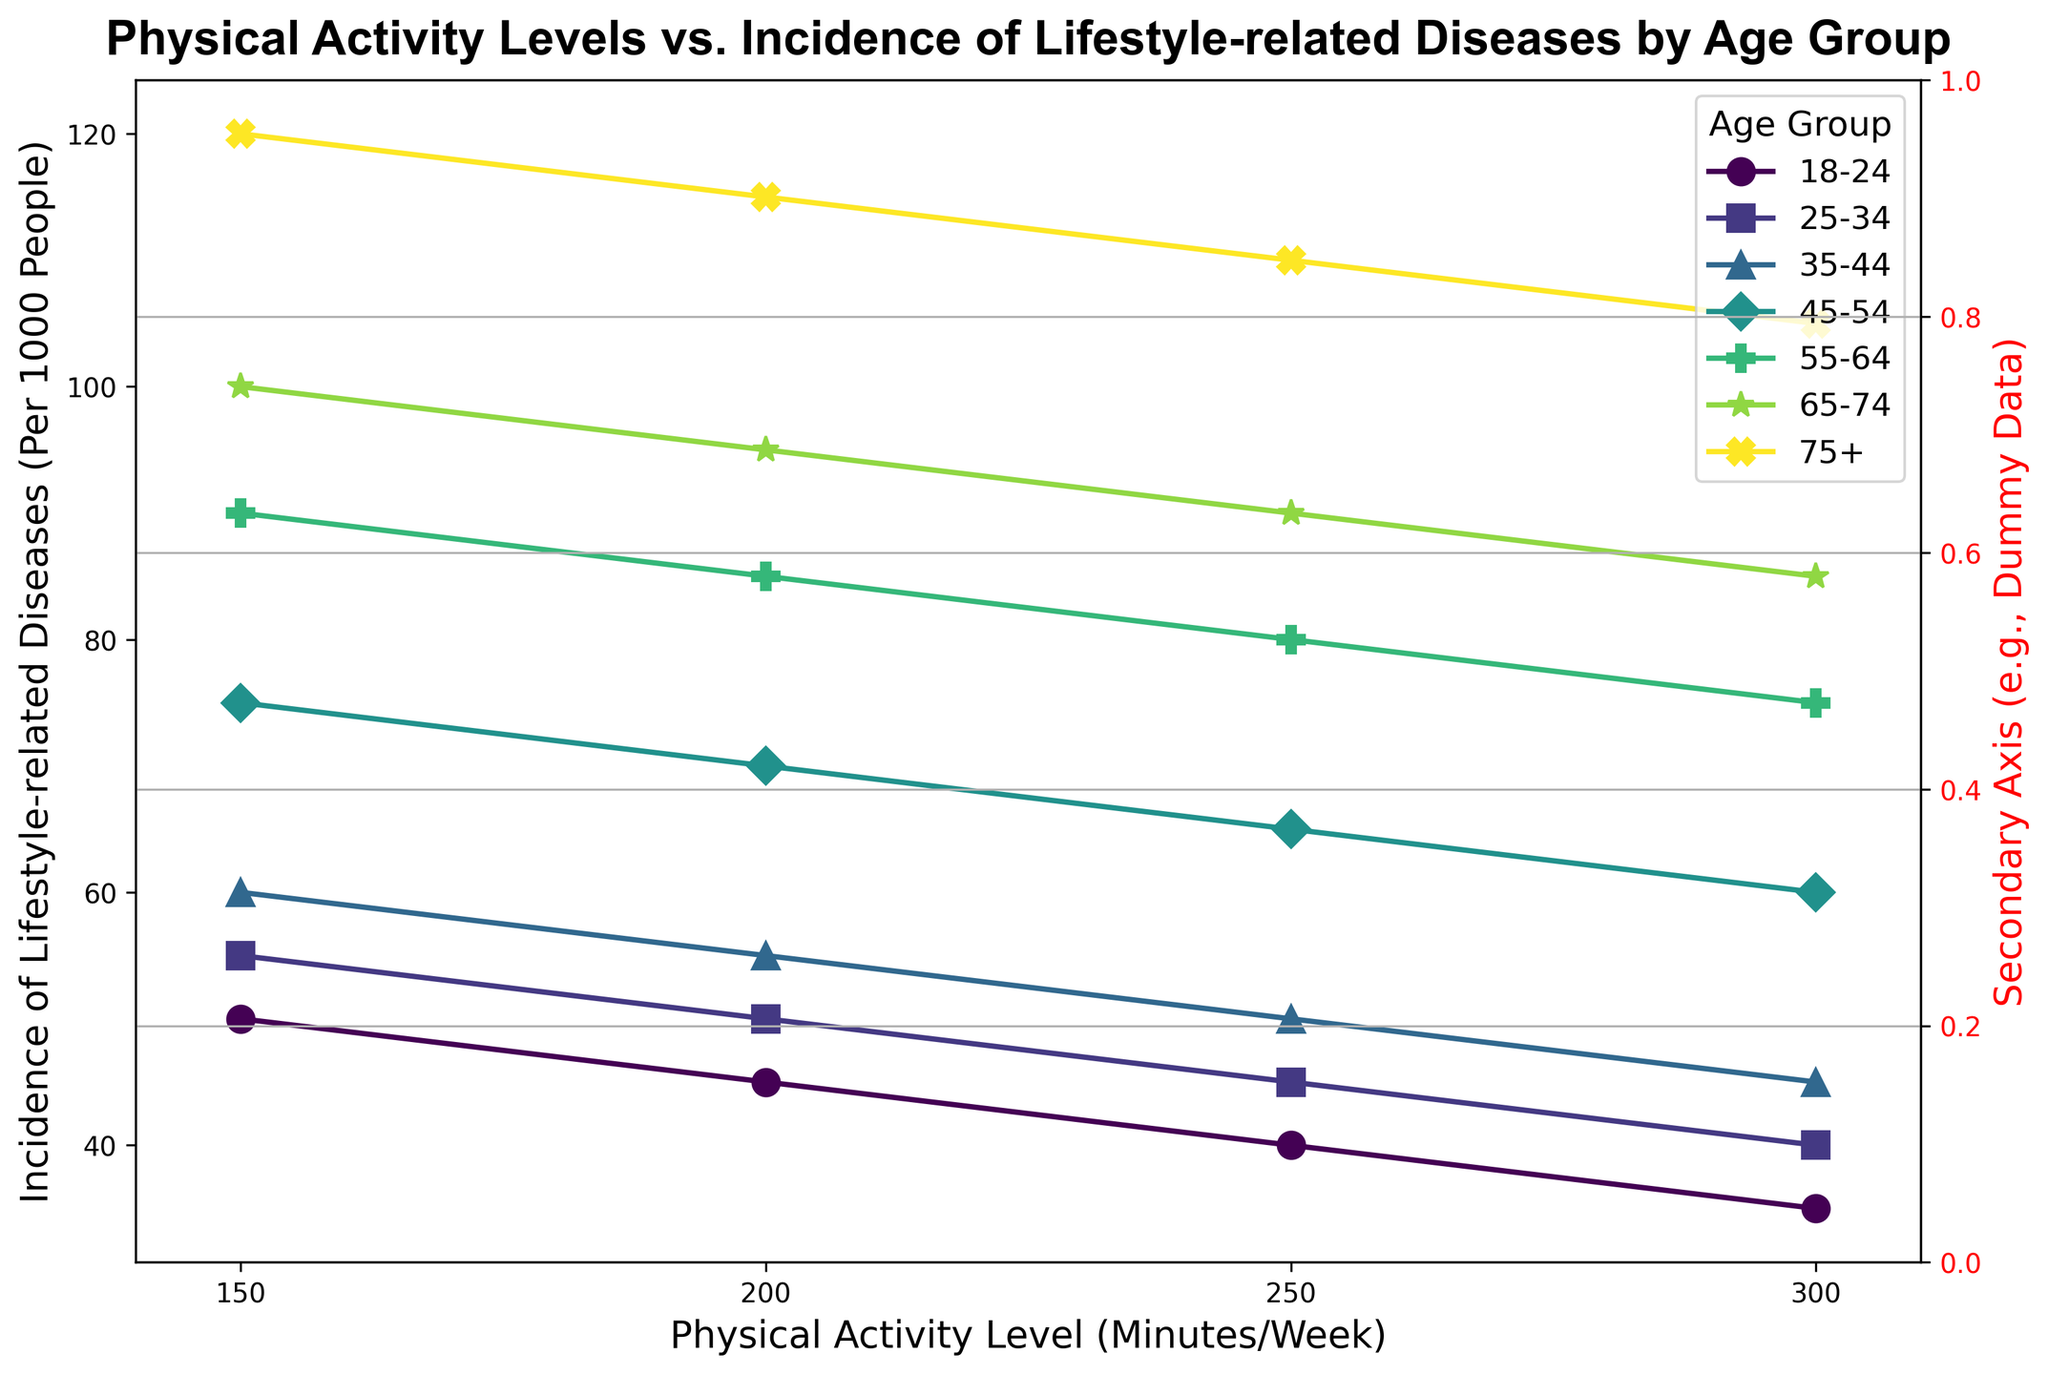What is the range of Physical Activity Level (Minutes/Week) represented in the figure? The x-axis of the figure ranges from the minimum value of Physical Activity Level to the maximum one. Observing the axis, it starts at 150 and ends at 300. Thus, the range is from 150 to 300 minutes per week.
Answer: 150 to 300 minutes per week Which age group has the highest incidence of lifestyle-related diseases at the lowest physical activity level? By looking at the points on the y-axis corresponding to 150 minutes per week on the x-axis, we observe that the 75+ age group has the highest value.
Answer: 75+ age group Compare the incidence of lifestyle-related diseases between the 18-24 and 45-54 age groups at 300 minutes of physical activity per week. At 300 minutes per week, you can observe the lines or markers representing the two age groups. The 18-24 age group has an incidence of 35 per 1000 people, whereas the 45-54 age group has an incidence of 60 per 1000 people.
Answer: 18-24 group: 35, 45-54 group: 60 What trend do you observe in the incidence of lifestyle-related diseases as physical activity increases within an age group? Examining the lines or markers for each age group as the physical activity level increases from left to right (150 to 300), we see a consistent downward trend. This indicates that as physical activity increases, the incidence of lifestyle-related diseases decreases within each age group.
Answer: Decreasing trend Which age group shows the smallest change in the incidence of lifestyle-related diseases between 150 and 300 minutes of physical activity per week? By comparing the vertical distances (y-axis differences) between the markers at 150 and 300 minutes for each age group, the 18-24 age group shows a decrease from 50 to 35, resulting in a change of 15, which is the smallest change observed.
Answer: 18-24 age group What is the average incidence of lifestyle-related diseases for the 55-64 age group across all physical activity levels? For 55-64 age group: (90+85+80+75)/4 = 330/4 = 82.5
Answer: 82.5 per 1000 people At 250 minutes of physical activity per week, which age group has the lowest incidence of lifestyle-related diseases? On the x-axis at 250 minutes, we observe the markers on the y-axis, and the 18-24 age group has the lowest incidence at 40 per 1000 people.
Answer: 18-24 age group Which color represents the 35-44 age group in the plot? By examining the legend of the plot, the 35-44 age group is color-coded in the plot. The specific color corresponding to 35-44 group can be found there, which is a shade of green.
Answer: A shade of green How much does the incidence of lifestyle-related diseases decrease for the 65-74 age group from 150 to 300 minutes per week of physical activity? For 65-74 age group: at 150 minutes, the incidence is 100, and at 300 minutes, it is 85. Therefore, the decrease is 100 - 85 = 15 per 1000 people.
Answer: 15 per 1000 people What is the secondary y-axis used for in the figure, and does it contain actual data? The secondary y-axis is labeled as "Secondary Axis (e.g., Dummy Data)" and is colored red. From the figure context, it appears to be a placeholder and does not contain actual data referring to physical activity or disease incidence.
Answer: Placeholder, no actual data 